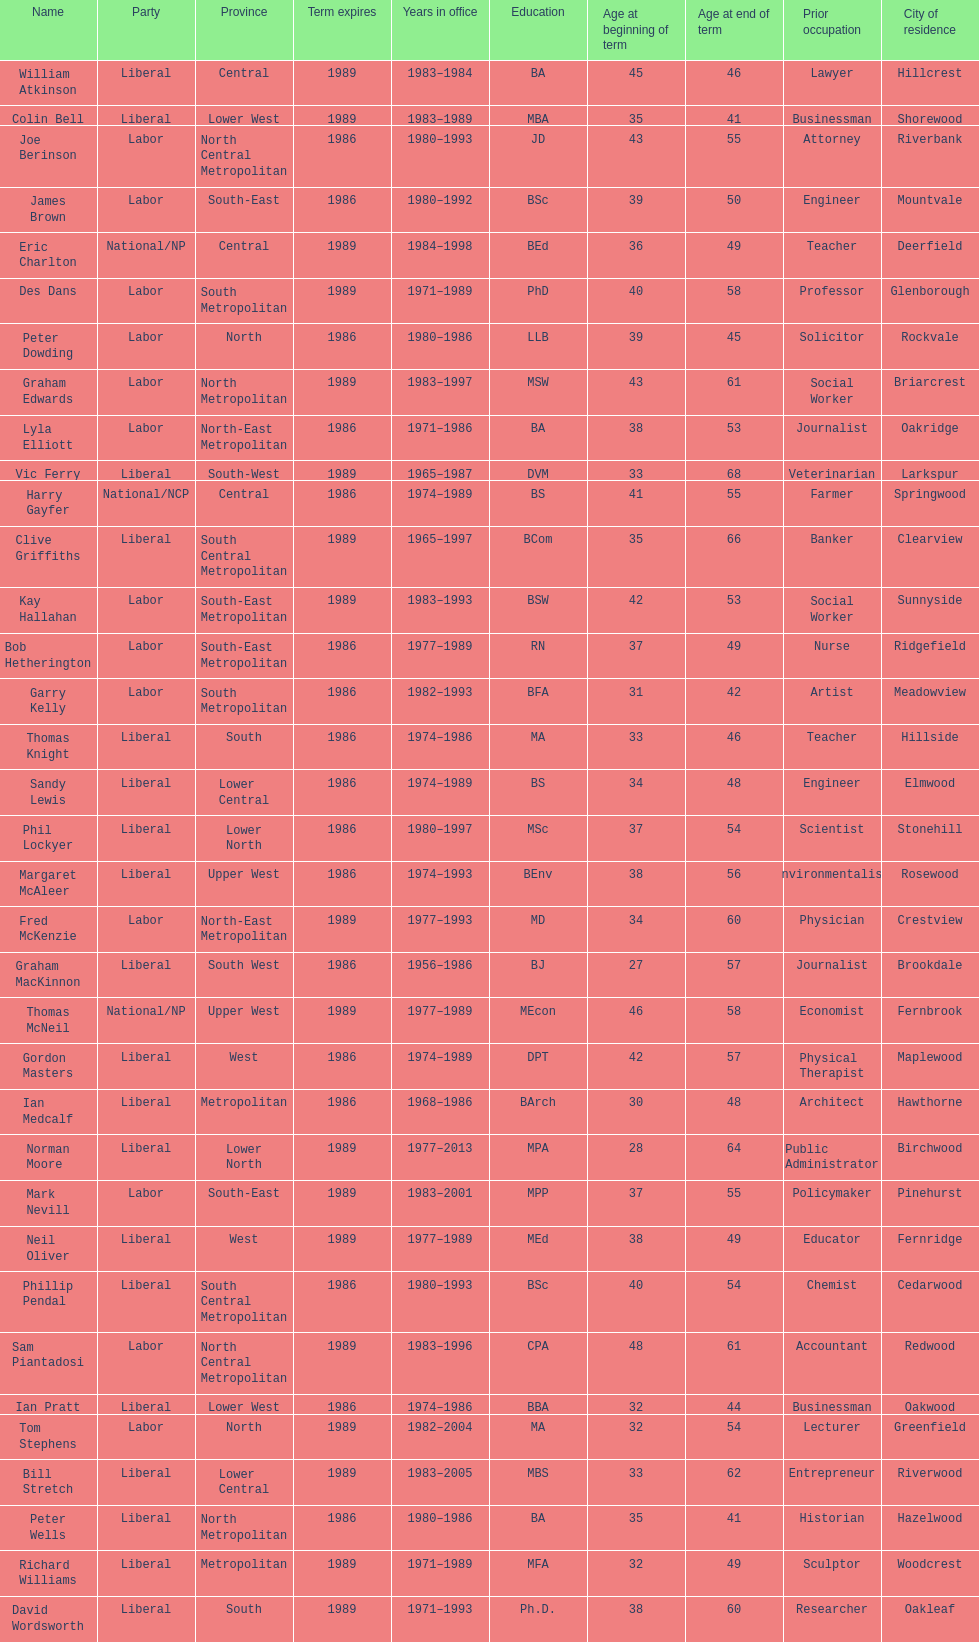What was phil lockyer's party? Liberal. 